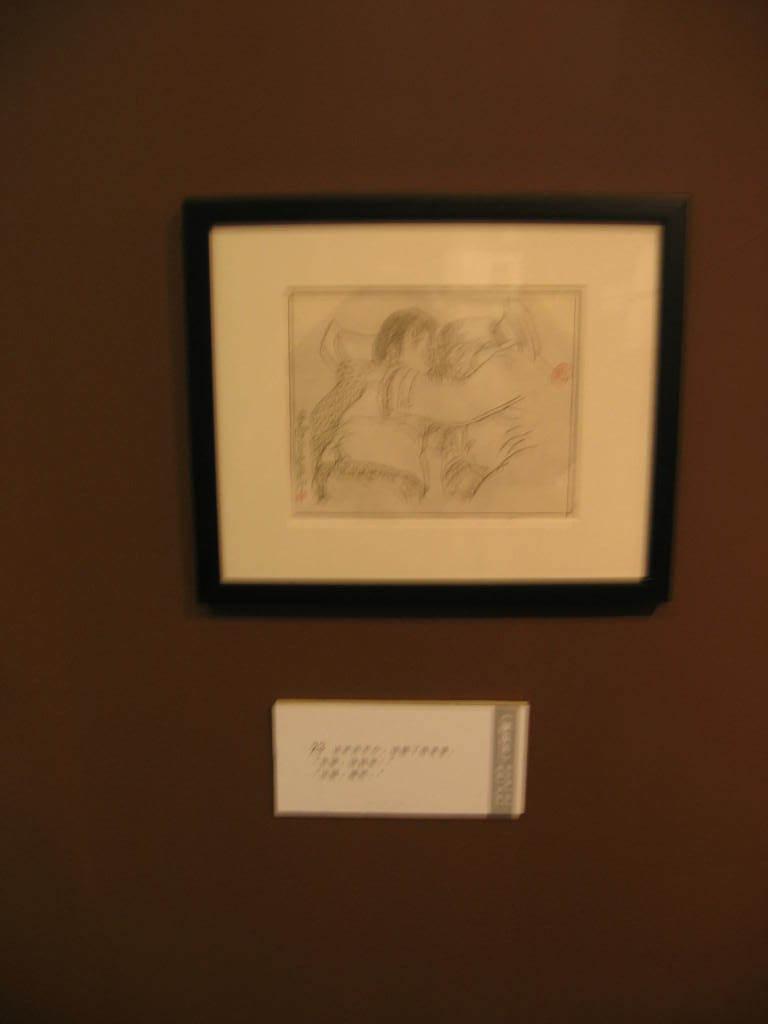Could you give a brief overview of what you see in this image? In the picture there is a wall, on the wall there is a frame present. 